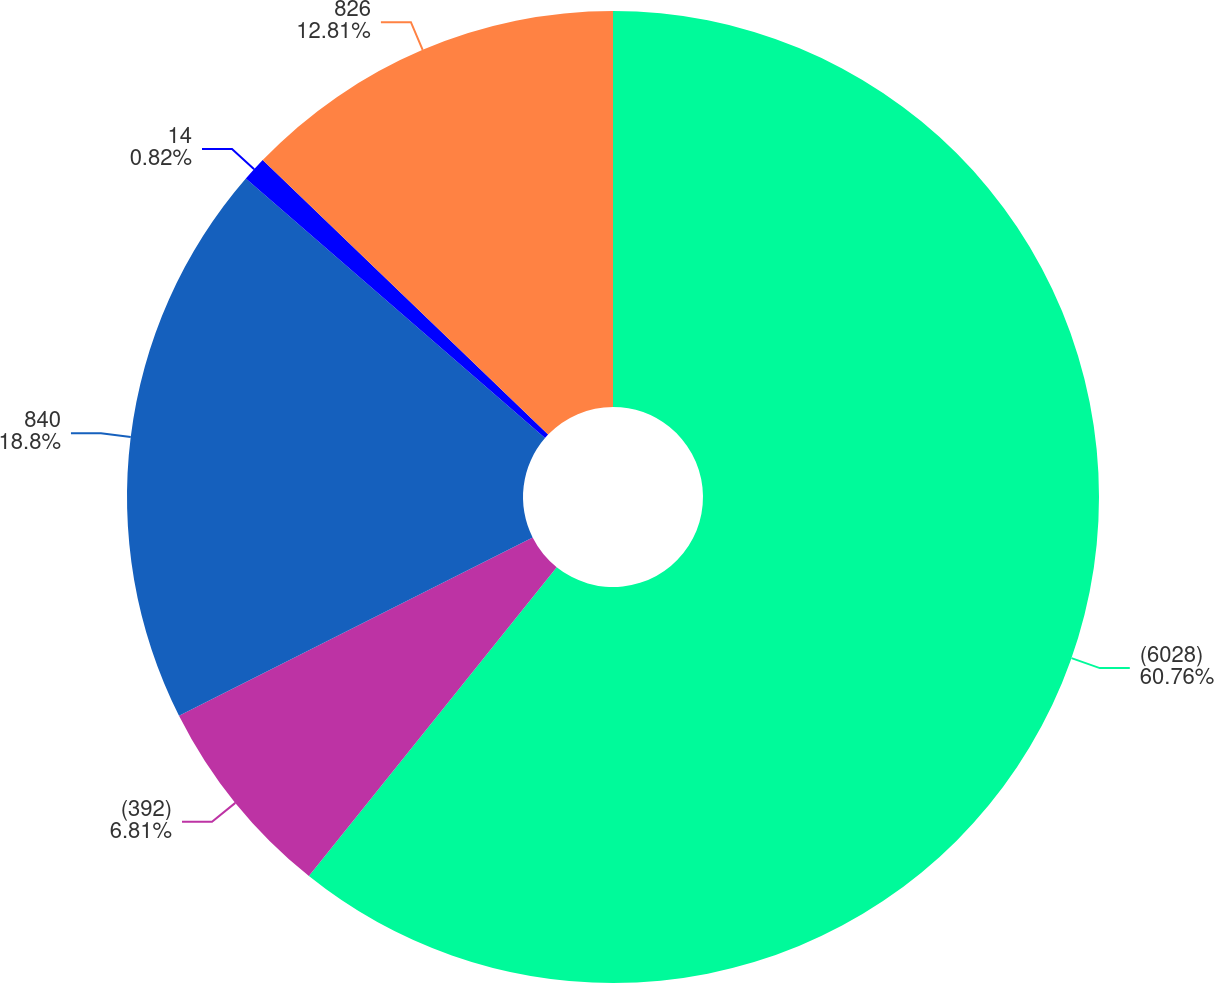<chart> <loc_0><loc_0><loc_500><loc_500><pie_chart><fcel>(6028)<fcel>(392)<fcel>840<fcel>14<fcel>826<nl><fcel>60.76%<fcel>6.81%<fcel>18.8%<fcel>0.82%<fcel>12.81%<nl></chart> 